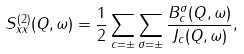Convert formula to latex. <formula><loc_0><loc_0><loc_500><loc_500>S _ { x x } ^ { ( 2 ) } ( Q , \omega ) = \frac { 1 } { 2 } \sum _ { c = \pm } \sum _ { \sigma = \pm } \frac { B _ { c } ^ { \sigma } ( Q , \omega ) } { J _ { c } ( Q , \omega ) } ,</formula> 